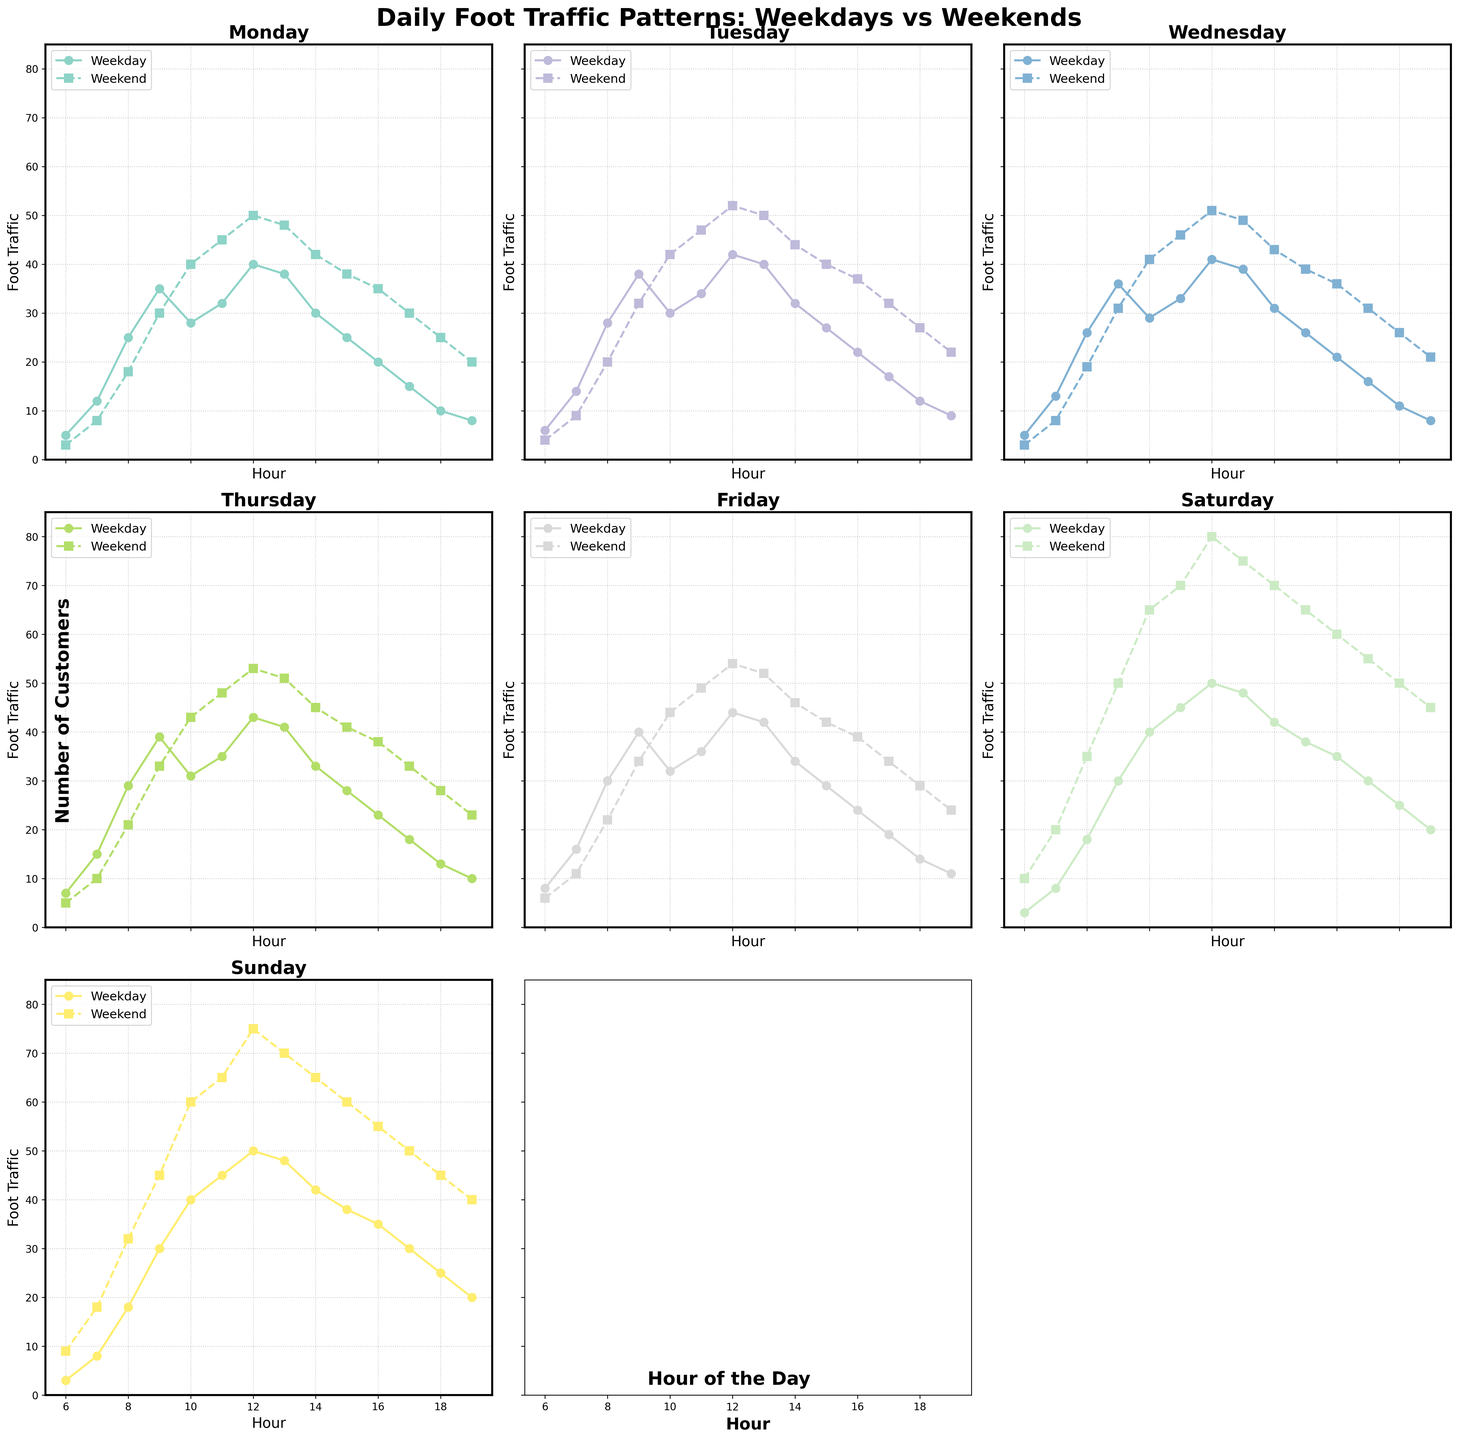What's the peak foot traffic hour on weekdays for Monday? Observing the Monday subplot, the highest foot traffic on weekdays appears to be at 12 PM (40 customers).
Answer: 12 PM Compare the peak weekend foot traffic on Saturday to Sunday. Which has a higher value and by how much? The Saturday subplot shows a peak weekend foot traffic of 80 at 12 PM, while the Sunday subplot shows a peak of 75 at 12 PM. The difference is 80 - 75 = 5 customers.
Answer: Saturday, by 5 customers What is the average foot traffic on weekdays at 3 PM across all days? For each day, collect weekday foot traffic at 3 PM: 
- Monday: 25
- Tuesday: 27
- Wednesday: 26 
- Thursday: 28
- Friday: 29
Summing these values: 25 + 27 + 26 + 28 + 29 = 135. The average is 135 / 5 = 27.
Answer: 27 Is there any day where the weekend foot traffic is lower than the weekday foot traffic at 9 AM? Comparing weekday and weekend foot traffic at 9 AM for each day:
- Monday: Weekday (35) vs Weekend (30)
- Tuesday: Weekday (38) vs Weekend (32)
- Wednesday: Weekday (36) vs Weekend (31)
All comparisons show weekend foot traffic is lower.
Answer: Yes, Monday, Tuesday, Wednesday What's the trend in weekend foot traffic from 6 AM to 9 AM on Saturdays? Is it increasing or decreasing? Observing the Saturday subplot for weekend traffic from 6 AM (10 customers) to 7 AM (20 customers) to 8 AM (35 customers) to 9 AM (50 customers), there's a clear increasing trend.
Answer: Increasing 